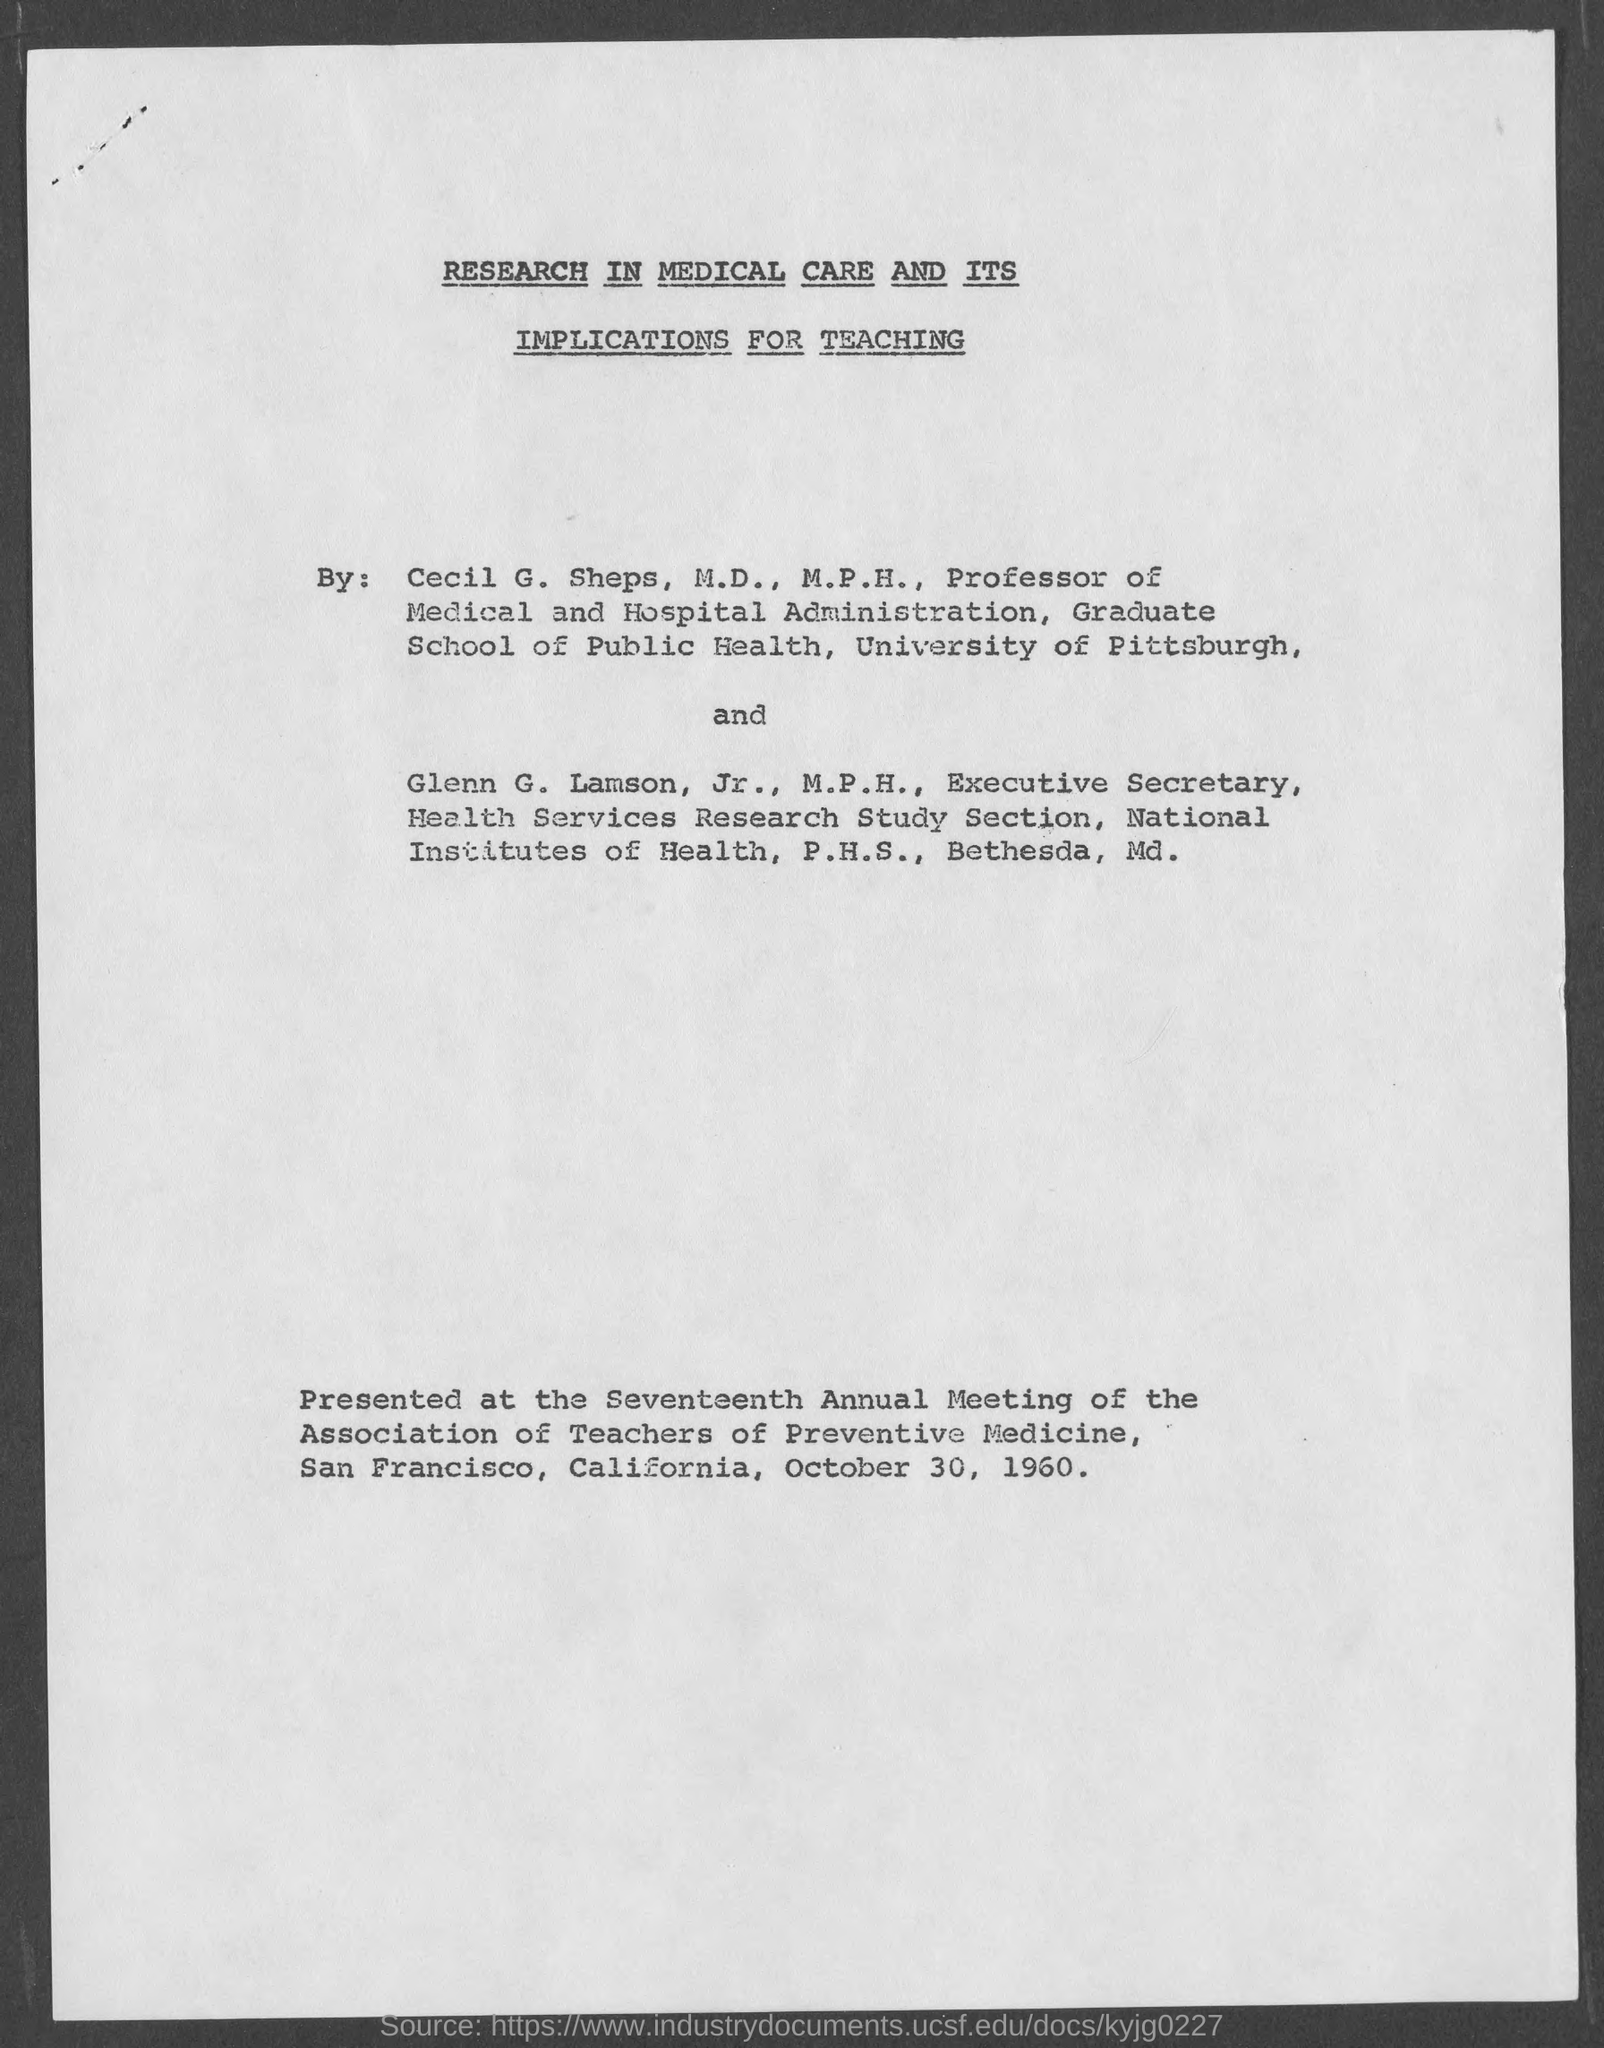What are the professional titles and affiliations of the authors of the document? Cecil G. Sheps holds the title of M.D., M.P.H., and is a Professor of Medical and Hospital Administration at the Graduate School of Public Health, University of Pittsburgh. Glenn G. Lamson, Jr., also with an M.P.H., is the Executive Secretary of the Health Services Research Study Section at the National Institutes of Health, P.H.S., in Bethesda, Maryland. 